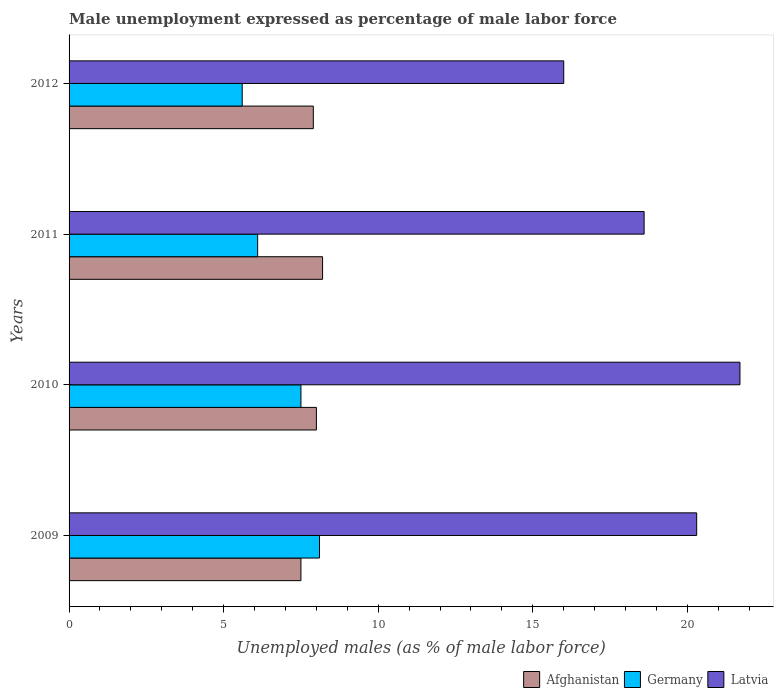How many different coloured bars are there?
Keep it short and to the point. 3. How many groups of bars are there?
Provide a succinct answer. 4. How many bars are there on the 1st tick from the bottom?
Offer a terse response. 3. In how many cases, is the number of bars for a given year not equal to the number of legend labels?
Give a very brief answer. 0. What is the unemployment in males in in Germany in 2009?
Your response must be concise. 8.1. Across all years, what is the maximum unemployment in males in in Germany?
Give a very brief answer. 8.1. Across all years, what is the minimum unemployment in males in in Germany?
Offer a terse response. 5.6. In which year was the unemployment in males in in Afghanistan minimum?
Offer a very short reply. 2009. What is the total unemployment in males in in Latvia in the graph?
Provide a short and direct response. 76.6. What is the difference between the unemployment in males in in Germany in 2011 and that in 2012?
Your answer should be compact. 0.5. What is the difference between the unemployment in males in in Afghanistan in 2009 and the unemployment in males in in Latvia in 2011?
Your answer should be compact. -11.1. What is the average unemployment in males in in Germany per year?
Provide a short and direct response. 6.83. In the year 2009, what is the difference between the unemployment in males in in Afghanistan and unemployment in males in in Germany?
Provide a short and direct response. -0.6. What is the ratio of the unemployment in males in in Latvia in 2010 to that in 2012?
Ensure brevity in your answer.  1.36. Is the difference between the unemployment in males in in Afghanistan in 2009 and 2012 greater than the difference between the unemployment in males in in Germany in 2009 and 2012?
Your response must be concise. No. What is the difference between the highest and the second highest unemployment in males in in Afghanistan?
Make the answer very short. 0.2. What is the difference between the highest and the lowest unemployment in males in in Afghanistan?
Offer a very short reply. 0.7. What does the 1st bar from the top in 2010 represents?
Offer a terse response. Latvia. What does the 1st bar from the bottom in 2009 represents?
Provide a succinct answer. Afghanistan. How many bars are there?
Offer a terse response. 12. What is the difference between two consecutive major ticks on the X-axis?
Offer a terse response. 5. Does the graph contain any zero values?
Your answer should be compact. No. Does the graph contain grids?
Your response must be concise. No. Where does the legend appear in the graph?
Make the answer very short. Bottom right. How many legend labels are there?
Give a very brief answer. 3. How are the legend labels stacked?
Provide a succinct answer. Horizontal. What is the title of the graph?
Your answer should be compact. Male unemployment expressed as percentage of male labor force. What is the label or title of the X-axis?
Your response must be concise. Unemployed males (as % of male labor force). What is the Unemployed males (as % of male labor force) in Afghanistan in 2009?
Your answer should be very brief. 7.5. What is the Unemployed males (as % of male labor force) of Germany in 2009?
Make the answer very short. 8.1. What is the Unemployed males (as % of male labor force) of Latvia in 2009?
Make the answer very short. 20.3. What is the Unemployed males (as % of male labor force) in Afghanistan in 2010?
Provide a short and direct response. 8. What is the Unemployed males (as % of male labor force) in Latvia in 2010?
Ensure brevity in your answer.  21.7. What is the Unemployed males (as % of male labor force) in Afghanistan in 2011?
Ensure brevity in your answer.  8.2. What is the Unemployed males (as % of male labor force) in Germany in 2011?
Your response must be concise. 6.1. What is the Unemployed males (as % of male labor force) of Latvia in 2011?
Your response must be concise. 18.6. What is the Unemployed males (as % of male labor force) in Afghanistan in 2012?
Ensure brevity in your answer.  7.9. What is the Unemployed males (as % of male labor force) in Germany in 2012?
Offer a terse response. 5.6. Across all years, what is the maximum Unemployed males (as % of male labor force) of Afghanistan?
Keep it short and to the point. 8.2. Across all years, what is the maximum Unemployed males (as % of male labor force) in Germany?
Provide a succinct answer. 8.1. Across all years, what is the maximum Unemployed males (as % of male labor force) of Latvia?
Your answer should be very brief. 21.7. Across all years, what is the minimum Unemployed males (as % of male labor force) in Afghanistan?
Make the answer very short. 7.5. Across all years, what is the minimum Unemployed males (as % of male labor force) in Germany?
Offer a terse response. 5.6. Across all years, what is the minimum Unemployed males (as % of male labor force) of Latvia?
Your response must be concise. 16. What is the total Unemployed males (as % of male labor force) in Afghanistan in the graph?
Make the answer very short. 31.6. What is the total Unemployed males (as % of male labor force) of Germany in the graph?
Provide a succinct answer. 27.3. What is the total Unemployed males (as % of male labor force) of Latvia in the graph?
Offer a very short reply. 76.6. What is the difference between the Unemployed males (as % of male labor force) in Germany in 2009 and that in 2010?
Make the answer very short. 0.6. What is the difference between the Unemployed males (as % of male labor force) in Latvia in 2009 and that in 2010?
Offer a terse response. -1.4. What is the difference between the Unemployed males (as % of male labor force) of Afghanistan in 2010 and that in 2011?
Provide a short and direct response. -0.2. What is the difference between the Unemployed males (as % of male labor force) in Afghanistan in 2010 and that in 2012?
Ensure brevity in your answer.  0.1. What is the difference between the Unemployed males (as % of male labor force) of Germany in 2010 and that in 2012?
Keep it short and to the point. 1.9. What is the difference between the Unemployed males (as % of male labor force) in Latvia in 2010 and that in 2012?
Offer a very short reply. 5.7. What is the difference between the Unemployed males (as % of male labor force) of Afghanistan in 2011 and that in 2012?
Ensure brevity in your answer.  0.3. What is the difference between the Unemployed males (as % of male labor force) of Germany in 2011 and that in 2012?
Ensure brevity in your answer.  0.5. What is the difference between the Unemployed males (as % of male labor force) of Afghanistan in 2009 and the Unemployed males (as % of male labor force) of Germany in 2011?
Your answer should be compact. 1.4. What is the difference between the Unemployed males (as % of male labor force) of Afghanistan in 2009 and the Unemployed males (as % of male labor force) of Latvia in 2011?
Your response must be concise. -11.1. What is the difference between the Unemployed males (as % of male labor force) of Afghanistan in 2009 and the Unemployed males (as % of male labor force) of Latvia in 2012?
Give a very brief answer. -8.5. What is the difference between the Unemployed males (as % of male labor force) in Germany in 2009 and the Unemployed males (as % of male labor force) in Latvia in 2012?
Ensure brevity in your answer.  -7.9. What is the difference between the Unemployed males (as % of male labor force) in Afghanistan in 2010 and the Unemployed males (as % of male labor force) in Germany in 2011?
Provide a succinct answer. 1.9. What is the difference between the Unemployed males (as % of male labor force) in Germany in 2010 and the Unemployed males (as % of male labor force) in Latvia in 2012?
Give a very brief answer. -8.5. What is the difference between the Unemployed males (as % of male labor force) in Germany in 2011 and the Unemployed males (as % of male labor force) in Latvia in 2012?
Your answer should be compact. -9.9. What is the average Unemployed males (as % of male labor force) in Afghanistan per year?
Provide a short and direct response. 7.9. What is the average Unemployed males (as % of male labor force) of Germany per year?
Keep it short and to the point. 6.83. What is the average Unemployed males (as % of male labor force) in Latvia per year?
Provide a short and direct response. 19.15. In the year 2009, what is the difference between the Unemployed males (as % of male labor force) in Germany and Unemployed males (as % of male labor force) in Latvia?
Offer a very short reply. -12.2. In the year 2010, what is the difference between the Unemployed males (as % of male labor force) of Afghanistan and Unemployed males (as % of male labor force) of Latvia?
Offer a very short reply. -13.7. In the year 2011, what is the difference between the Unemployed males (as % of male labor force) in Afghanistan and Unemployed males (as % of male labor force) in Latvia?
Keep it short and to the point. -10.4. In the year 2012, what is the difference between the Unemployed males (as % of male labor force) in Afghanistan and Unemployed males (as % of male labor force) in Germany?
Provide a short and direct response. 2.3. What is the ratio of the Unemployed males (as % of male labor force) in Germany in 2009 to that in 2010?
Provide a short and direct response. 1.08. What is the ratio of the Unemployed males (as % of male labor force) of Latvia in 2009 to that in 2010?
Offer a terse response. 0.94. What is the ratio of the Unemployed males (as % of male labor force) of Afghanistan in 2009 to that in 2011?
Make the answer very short. 0.91. What is the ratio of the Unemployed males (as % of male labor force) in Germany in 2009 to that in 2011?
Provide a succinct answer. 1.33. What is the ratio of the Unemployed males (as % of male labor force) of Latvia in 2009 to that in 2011?
Make the answer very short. 1.09. What is the ratio of the Unemployed males (as % of male labor force) of Afghanistan in 2009 to that in 2012?
Make the answer very short. 0.95. What is the ratio of the Unemployed males (as % of male labor force) in Germany in 2009 to that in 2012?
Offer a very short reply. 1.45. What is the ratio of the Unemployed males (as % of male labor force) of Latvia in 2009 to that in 2012?
Offer a terse response. 1.27. What is the ratio of the Unemployed males (as % of male labor force) in Afghanistan in 2010 to that in 2011?
Offer a terse response. 0.98. What is the ratio of the Unemployed males (as % of male labor force) of Germany in 2010 to that in 2011?
Your response must be concise. 1.23. What is the ratio of the Unemployed males (as % of male labor force) of Afghanistan in 2010 to that in 2012?
Your response must be concise. 1.01. What is the ratio of the Unemployed males (as % of male labor force) in Germany in 2010 to that in 2012?
Your answer should be compact. 1.34. What is the ratio of the Unemployed males (as % of male labor force) of Latvia in 2010 to that in 2012?
Your answer should be very brief. 1.36. What is the ratio of the Unemployed males (as % of male labor force) of Afghanistan in 2011 to that in 2012?
Provide a succinct answer. 1.04. What is the ratio of the Unemployed males (as % of male labor force) of Germany in 2011 to that in 2012?
Provide a short and direct response. 1.09. What is the ratio of the Unemployed males (as % of male labor force) of Latvia in 2011 to that in 2012?
Give a very brief answer. 1.16. What is the difference between the highest and the second highest Unemployed males (as % of male labor force) in Latvia?
Offer a very short reply. 1.4. 